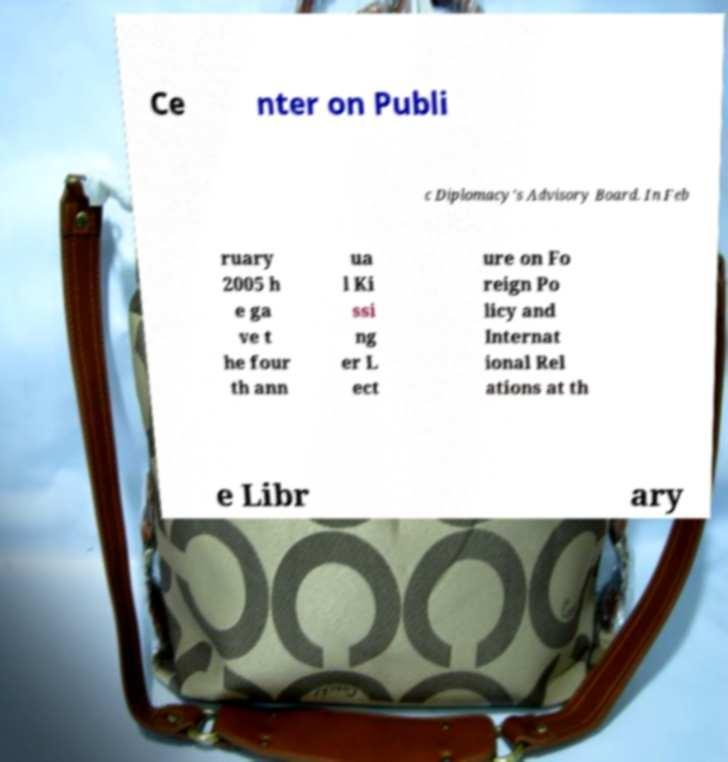Please identify and transcribe the text found in this image. Ce nter on Publi c Diplomacy's Advisory Board. In Feb ruary 2005 h e ga ve t he four th ann ua l Ki ssi ng er L ect ure on Fo reign Po licy and Internat ional Rel ations at th e Libr ary 